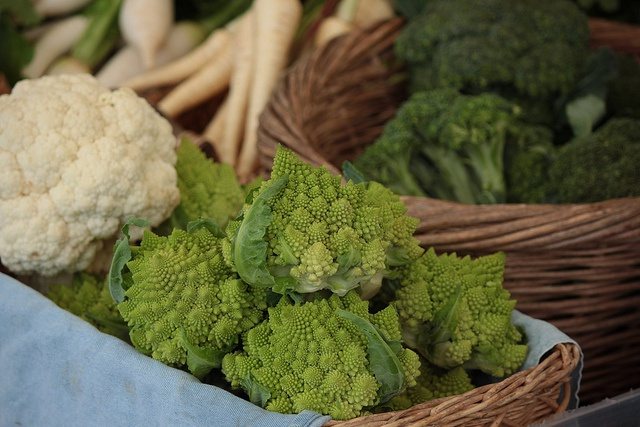Describe the objects in this image and their specific colors. I can see broccoli in darkgreen and black tones, broccoli in darkgreen and olive tones, broccoli in darkgreen, olive, and black tones, broccoli in darkgreen, olive, and black tones, and broccoli in darkgreen, olive, and black tones in this image. 